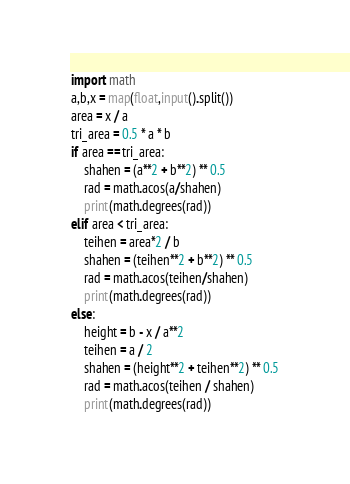Convert code to text. <code><loc_0><loc_0><loc_500><loc_500><_Python_>import math
a,b,x = map(float,input().split())
area = x / a
tri_area = 0.5 * a * b
if area == tri_area:
    shahen = (a**2 + b**2) ** 0.5
    rad = math.acos(a/shahen)
    print(math.degrees(rad))
elif area < tri_area:
    teihen = area*2 / b
    shahen = (teihen**2 + b**2) ** 0.5
    rad = math.acos(teihen/shahen)
    print(math.degrees(rad))
else:
    height = b - x / a**2
    teihen = a / 2
    shahen = (height**2 + teihen**2) ** 0.5
    rad = math.acos(teihen / shahen)
    print(math.degrees(rad))
</code> 